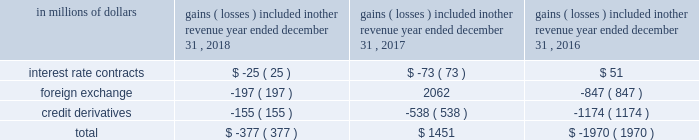For the years ended december a031 , 2018 , 2017 and 2016 , the amounts recognized in principal transactions in the consolidated statement of income related to derivatives not designated in a qualifying hedging relationship , as well as the underlying non-derivative instruments , are presented in note a06 to the consolidated financial statements .
Citigroup presents this disclosure by showing derivative gains and losses related to its trading activities together with gains and losses related to non-derivative instruments within the same trading portfolios , as this represents how these portfolios are risk managed .
The amounts recognized in other revenue in the consolidated statement of income related to derivatives not designated in a qualifying hedging relationship are shown below .
The table below does not include any offsetting gains ( losses ) on the economically hedged items to the extent that such amounts are also recorded in other revenue .
Gains ( losses ) included in other revenue year ended december 31 .
Accounting for derivative hedging citigroup accounts for its hedging activities in accordance with asc 815 , derivatives and hedging .
As a general rule , hedge accounting is permitted where the company is exposed to a particular risk , such as interest rate or foreign exchange risk , that causes changes in the fair value of an asset or liability or variability in the expected future cash flows of an existing asset , liability or a forecasted transaction that may affect earnings .
Derivative contracts hedging the risks associated with changes in fair value are referred to as fair value hedges , while contracts hedging the variability of expected future cash flows are cash flow hedges .
Hedges that utilize derivatives or debt instruments to manage the foreign exchange risk associated with equity investments in non-u.s.-dollar-functional- currency foreign subsidiaries ( net investment in a foreign operation ) are net investment hedges .
To qualify as an accounting hedge under the hedge accounting rules ( versus an economic hedge where hedge accounting is not applied ) , a hedging relationship must be highly effective in offsetting the risk designated as being hedged .
The hedging relationship must be formally documented at inception , detailing the particular risk management objective and strategy for the hedge .
This includes the item and risk ( s ) being hedged , the hedging instrument being used and how effectiveness will be assessed .
The effectiveness of these hedging relationships is evaluated at hedge inception and on an ongoing basis both on a retrospective and prospective basis , typically using quantitative measures of correlation , with hedge ineffectiveness measured and recorded in current earnings .
Hedge effectiveness assessment methodologies are performed in a similar manner for similar hedges , and are used consistently throughout the hedging relationships .
The assessment of effectiveness may exclude changes in the value of the hedged item that are unrelated to the risks being hedged and the changes in fair value of the derivative associated with time value .
Prior to january 1 , 2018 , these excluded items were recognized in current earnings for the hedging derivative , while changes in the value of a hedged item that were not related to the hedged risk were not recorded .
Upon adoption of asc 2017-12 , citi excludes changes in the cross currency basis associated with cross currency swaps from the assessment of hedge effectiveness and records it in other comprehensive income .
Discontinued hedge accounting a hedging instrument must be highly effective in accomplishing the hedge objective of offsetting either changes in the fair value or cash flows of the hedged item for the risk being hedged .
Management may voluntarily de-designate an accounting hedge at any time , but if a hedging relationship is not highly effective , it no longer qualifies for hedge accounting and must be de-designated .
Subsequent changes in the fair value of the derivative are recognized in other revenue or principal transactions , similar to trading derivatives , with no offset recorded related to the hedged item .
For fair value hedges , any changes in the fair value of the hedged item remain as part of the basis of the asset or liability and are ultimately realized as an element of the yield on the item .
For cash flow hedges , changes in fair value of the end-user derivative remain in accumulated other comprehensive income ( loss ) ( aoci ) and are included in the earnings of future periods when the forecasted hedged cash flows impact earnings .
However , if it becomes probable that some or all of the hedged forecasted transactions will not occur , any amounts that remain in aoci related to these transactions must be immediately reflected in other revenue .
The foregoing criteria are applied on a decentralized basis , consistent with the level at which market risk is managed , but are subject to various limits and controls .
The underlying asset , liability or forecasted transaction may be an individual item or a portfolio of similar items. .
What was the change in millions in total gains ( losses ) included in other revenue between the year ended december 31 , 2016 and 2017? 
Computations: (1451 - -1970)
Answer: 3421.0. 